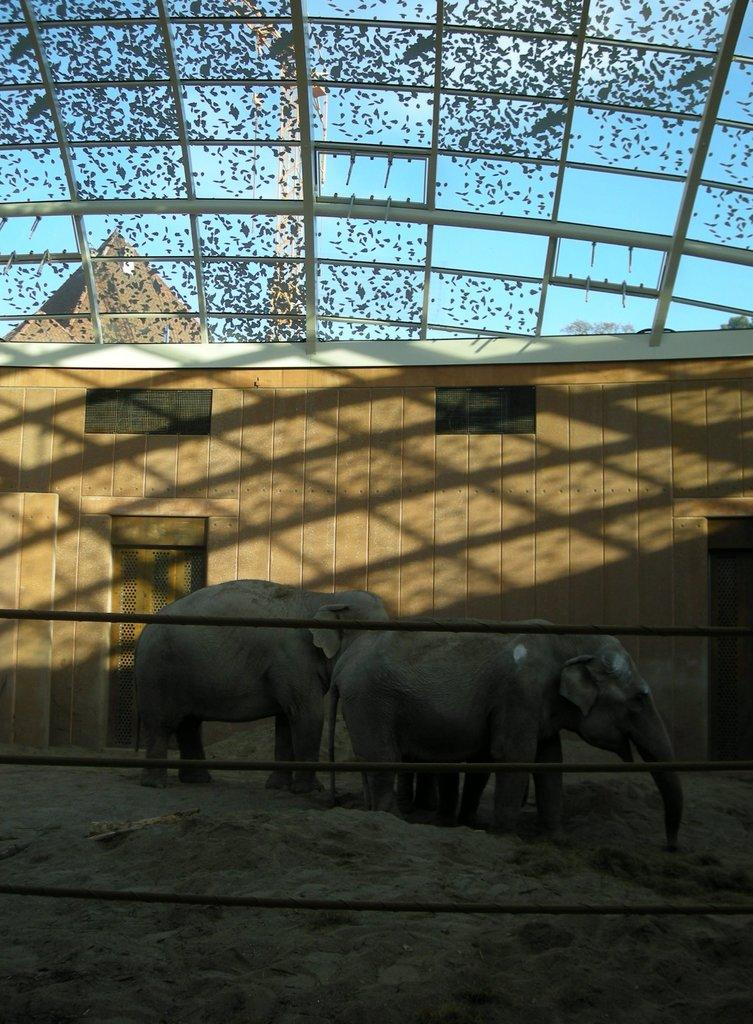What objects can be seen in the image? There are rods and some objects in the image. What animals are present in the image? There are elephants on the ground in the image. What type of structure is visible in the image? There is a shed in the image. What can be seen in the background of the image? The sky is visible in the background of the image. What type of chalk is being used to draw on the side of the shed in the image? There is no chalk or drawing visible on the shed in the image. What type of expansion is occurring in the image? There is no expansion occurring in the image; it is a static scene. 